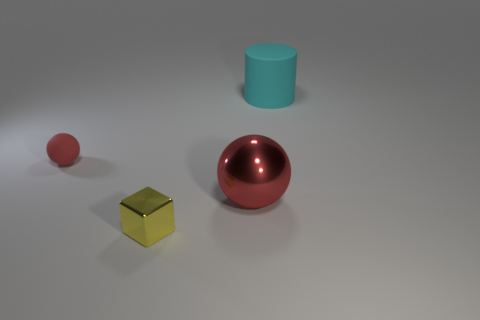Is the size of the ball on the right side of the matte sphere the same as the thing to the left of the small yellow object?
Give a very brief answer. No. What material is the red object that is right of the matte object to the left of the big cylinder made of?
Ensure brevity in your answer.  Metal. Are there fewer large red metal balls that are behind the big cyan thing than large red metal things?
Keep it short and to the point. Yes. The thing that is the same material as the cyan cylinder is what shape?
Keep it short and to the point. Sphere. How many other things are there of the same shape as the large cyan thing?
Provide a succinct answer. 0. What number of red objects are either small matte objects or large cylinders?
Ensure brevity in your answer.  1. Is the large metal thing the same shape as the red matte thing?
Provide a succinct answer. Yes. Are there any large cyan objects that are in front of the red sphere in front of the tiny red rubber ball?
Keep it short and to the point. No. Are there an equal number of big metal spheres left of the red matte thing and cyan matte objects?
Keep it short and to the point. No. What number of other objects are there of the same size as the red metal sphere?
Your answer should be compact. 1. 